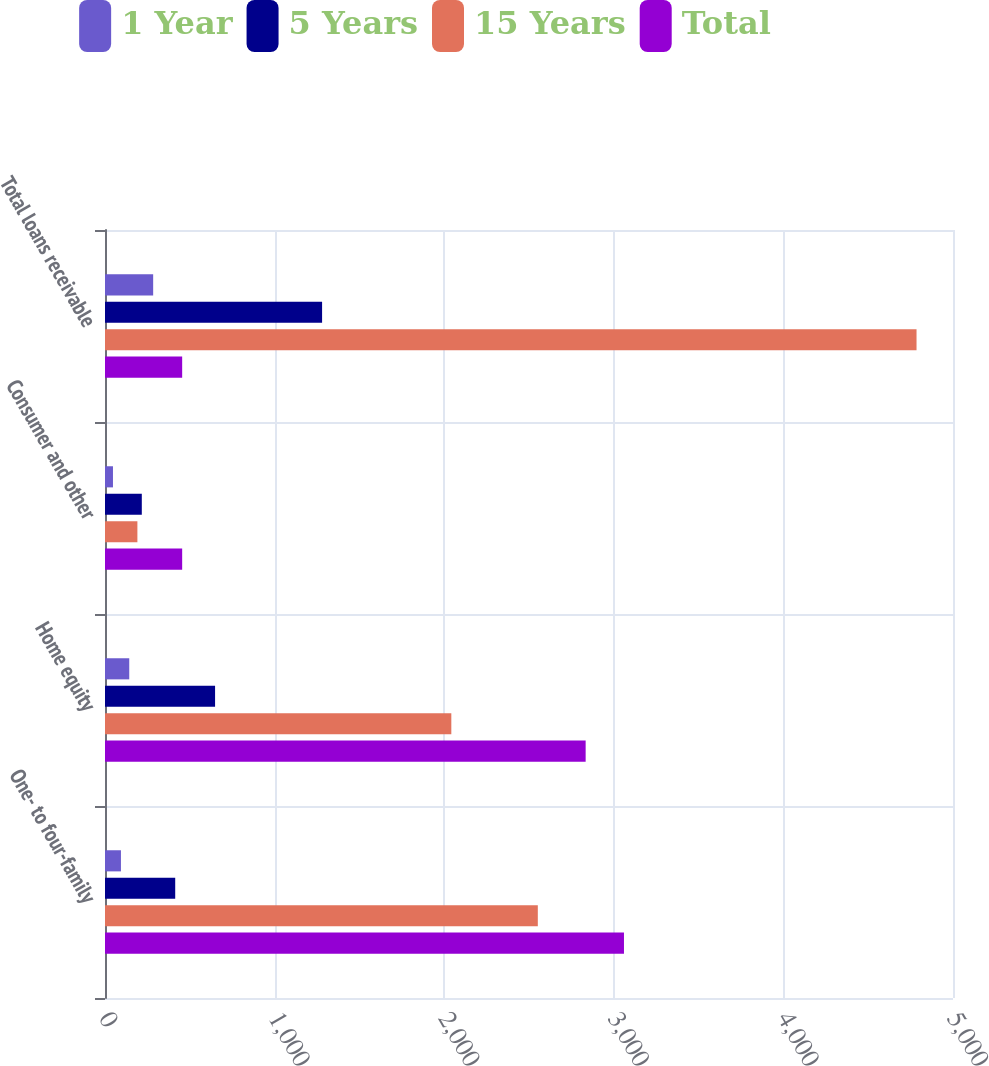<chart> <loc_0><loc_0><loc_500><loc_500><stacked_bar_chart><ecel><fcel>One- to four-family<fcel>Home equity<fcel>Consumer and other<fcel>Total loans receivable<nl><fcel>1 Year<fcel>94<fcel>143<fcel>47<fcel>284<nl><fcel>5 Years<fcel>414<fcel>649<fcel>217<fcel>1280<nl><fcel>15 Years<fcel>2552<fcel>2042<fcel>191<fcel>4785<nl><fcel>Total<fcel>3060<fcel>2834<fcel>455<fcel>455<nl></chart> 